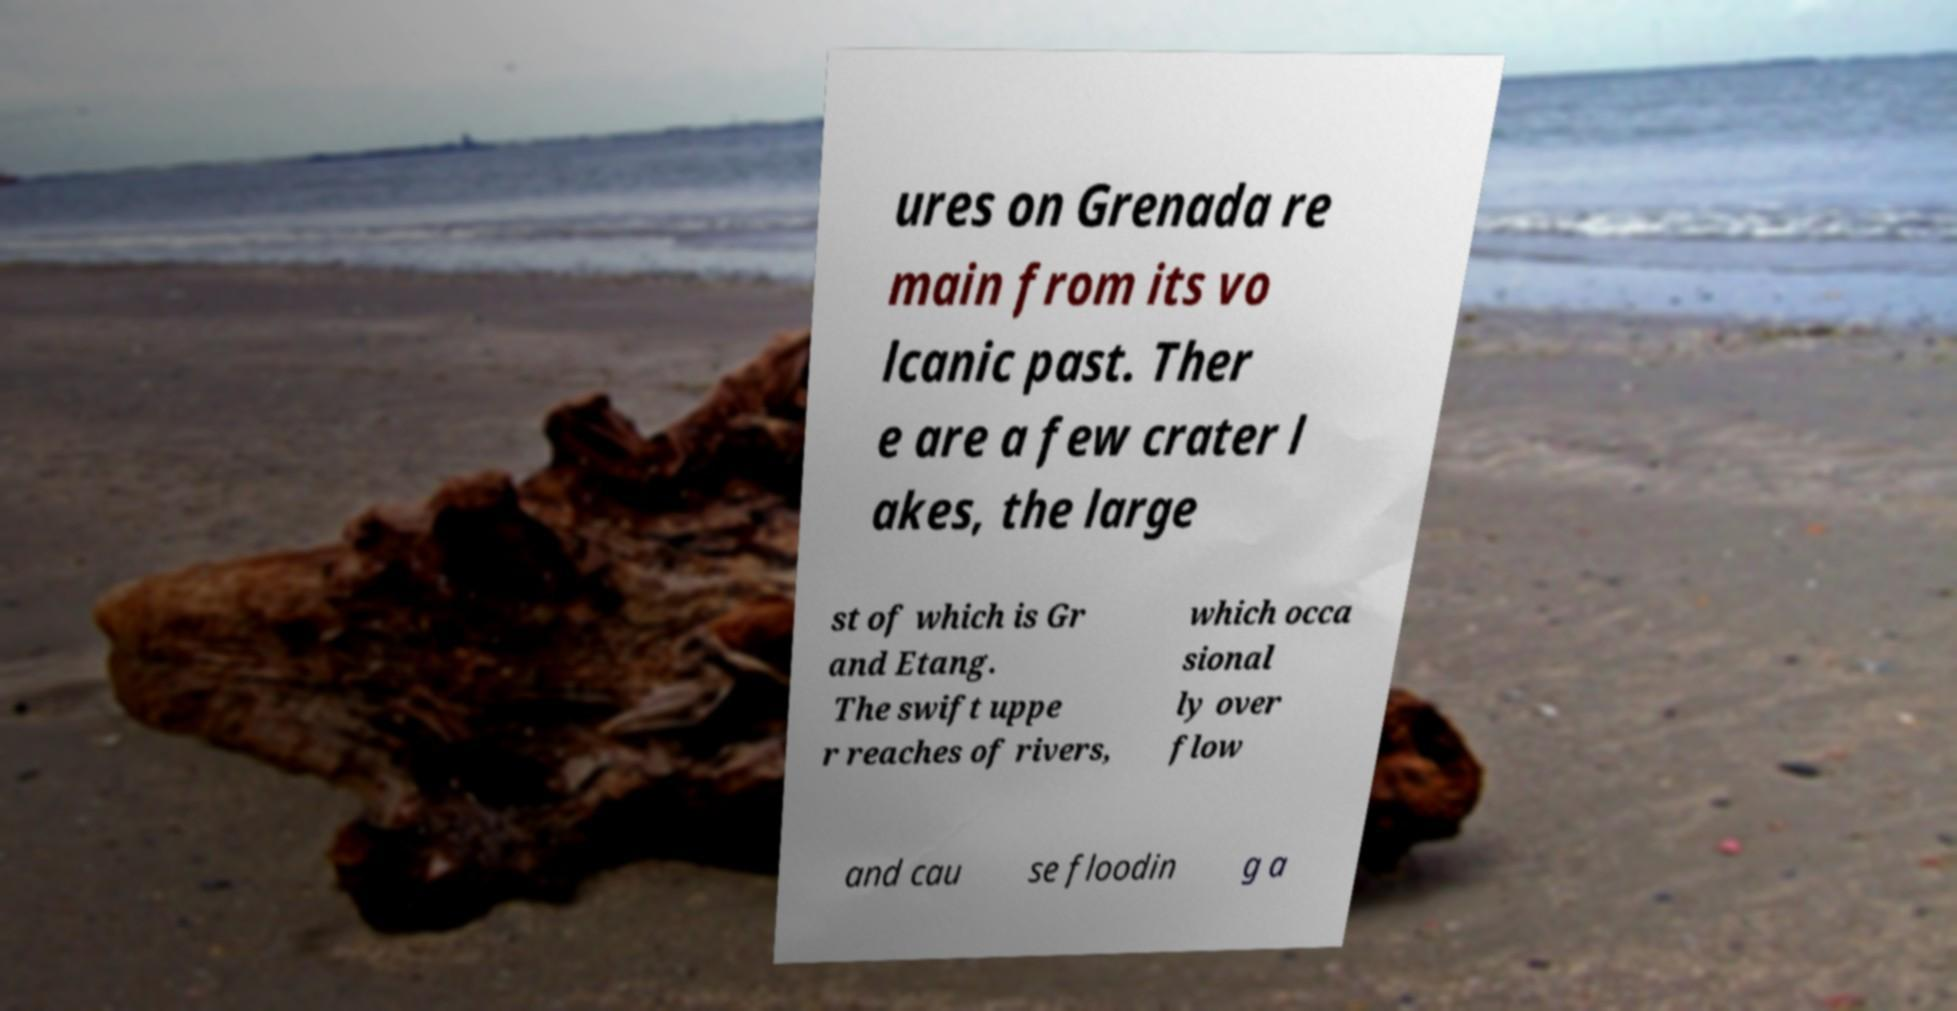Could you assist in decoding the text presented in this image and type it out clearly? ures on Grenada re main from its vo lcanic past. Ther e are a few crater l akes, the large st of which is Gr and Etang. The swift uppe r reaches of rivers, which occa sional ly over flow and cau se floodin g a 